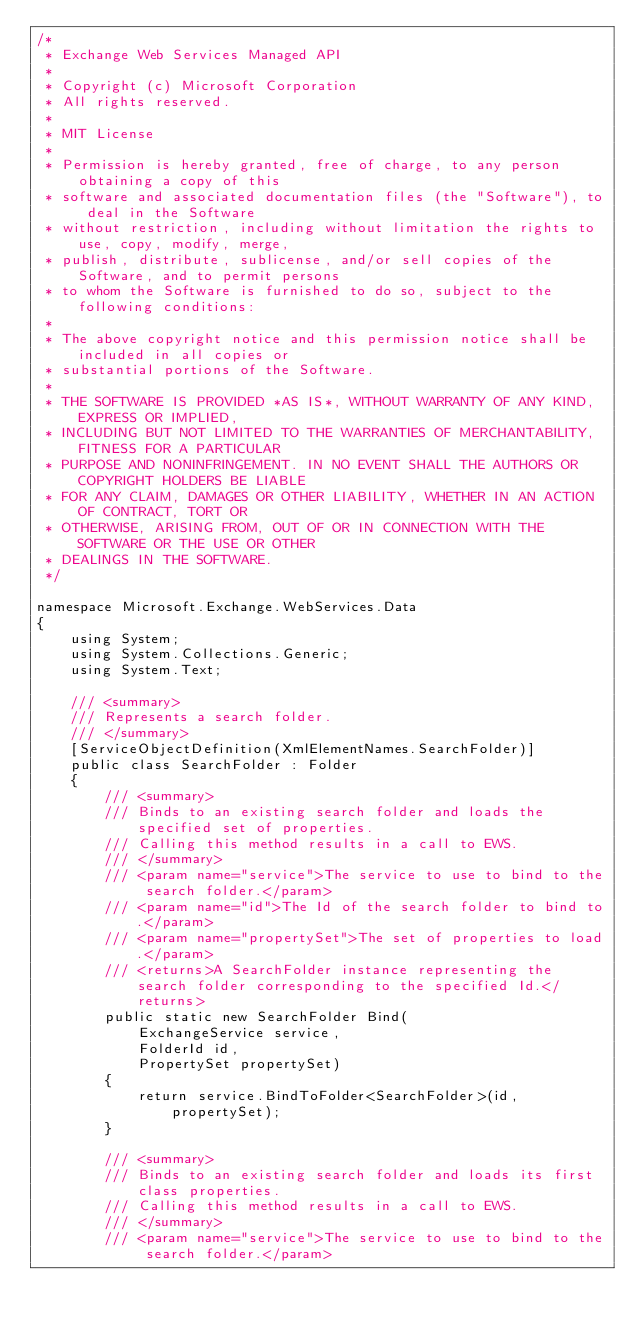Convert code to text. <code><loc_0><loc_0><loc_500><loc_500><_C#_>/*
 * Exchange Web Services Managed API
 *
 * Copyright (c) Microsoft Corporation
 * All rights reserved.
 *
 * MIT License
 *
 * Permission is hereby granted, free of charge, to any person obtaining a copy of this
 * software and associated documentation files (the "Software"), to deal in the Software
 * without restriction, including without limitation the rights to use, copy, modify, merge,
 * publish, distribute, sublicense, and/or sell copies of the Software, and to permit persons
 * to whom the Software is furnished to do so, subject to the following conditions:
 *
 * The above copyright notice and this permission notice shall be included in all copies or
 * substantial portions of the Software.
 *
 * THE SOFTWARE IS PROVIDED *AS IS*, WITHOUT WARRANTY OF ANY KIND, EXPRESS OR IMPLIED,
 * INCLUDING BUT NOT LIMITED TO THE WARRANTIES OF MERCHANTABILITY, FITNESS FOR A PARTICULAR
 * PURPOSE AND NONINFRINGEMENT. IN NO EVENT SHALL THE AUTHORS OR COPYRIGHT HOLDERS BE LIABLE
 * FOR ANY CLAIM, DAMAGES OR OTHER LIABILITY, WHETHER IN AN ACTION OF CONTRACT, TORT OR
 * OTHERWISE, ARISING FROM, OUT OF OR IN CONNECTION WITH THE SOFTWARE OR THE USE OR OTHER
 * DEALINGS IN THE SOFTWARE.
 */

namespace Microsoft.Exchange.WebServices.Data
{
    using System;
    using System.Collections.Generic;
    using System.Text;

    /// <summary>
    /// Represents a search folder. 
    /// </summary>
    [ServiceObjectDefinition(XmlElementNames.SearchFolder)]
    public class SearchFolder : Folder
    {
        /// <summary>
        /// Binds to an existing search folder and loads the specified set of properties.
        /// Calling this method results in a call to EWS.
        /// </summary>
        /// <param name="service">The service to use to bind to the search folder.</param>
        /// <param name="id">The Id of the search folder to bind to.</param>
        /// <param name="propertySet">The set of properties to load.</param>
        /// <returns>A SearchFolder instance representing the search folder corresponding to the specified Id.</returns>
        public static new SearchFolder Bind(
            ExchangeService service,
            FolderId id,
            PropertySet propertySet)
        {
            return service.BindToFolder<SearchFolder>(id, propertySet);
        }

        /// <summary>
        /// Binds to an existing search folder and loads its first class properties.
        /// Calling this method results in a call to EWS.
        /// </summary>
        /// <param name="service">The service to use to bind to the search folder.</param></code> 